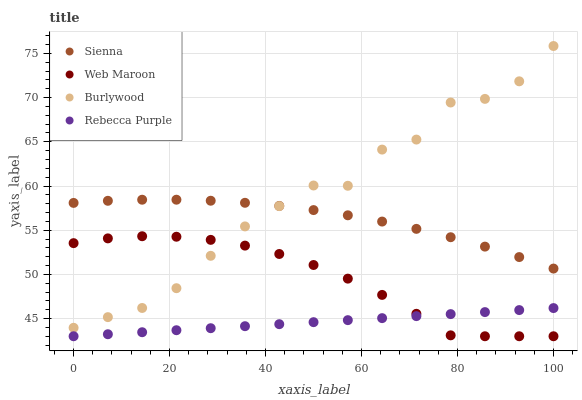Does Rebecca Purple have the minimum area under the curve?
Answer yes or no. Yes. Does Burlywood have the maximum area under the curve?
Answer yes or no. Yes. Does Web Maroon have the minimum area under the curve?
Answer yes or no. No. Does Web Maroon have the maximum area under the curve?
Answer yes or no. No. Is Rebecca Purple the smoothest?
Answer yes or no. Yes. Is Burlywood the roughest?
Answer yes or no. Yes. Is Web Maroon the smoothest?
Answer yes or no. No. Is Web Maroon the roughest?
Answer yes or no. No. Does Web Maroon have the lowest value?
Answer yes or no. Yes. Does Burlywood have the lowest value?
Answer yes or no. No. Does Burlywood have the highest value?
Answer yes or no. Yes. Does Web Maroon have the highest value?
Answer yes or no. No. Is Web Maroon less than Sienna?
Answer yes or no. Yes. Is Burlywood greater than Rebecca Purple?
Answer yes or no. Yes. Does Sienna intersect Burlywood?
Answer yes or no. Yes. Is Sienna less than Burlywood?
Answer yes or no. No. Is Sienna greater than Burlywood?
Answer yes or no. No. Does Web Maroon intersect Sienna?
Answer yes or no. No. 